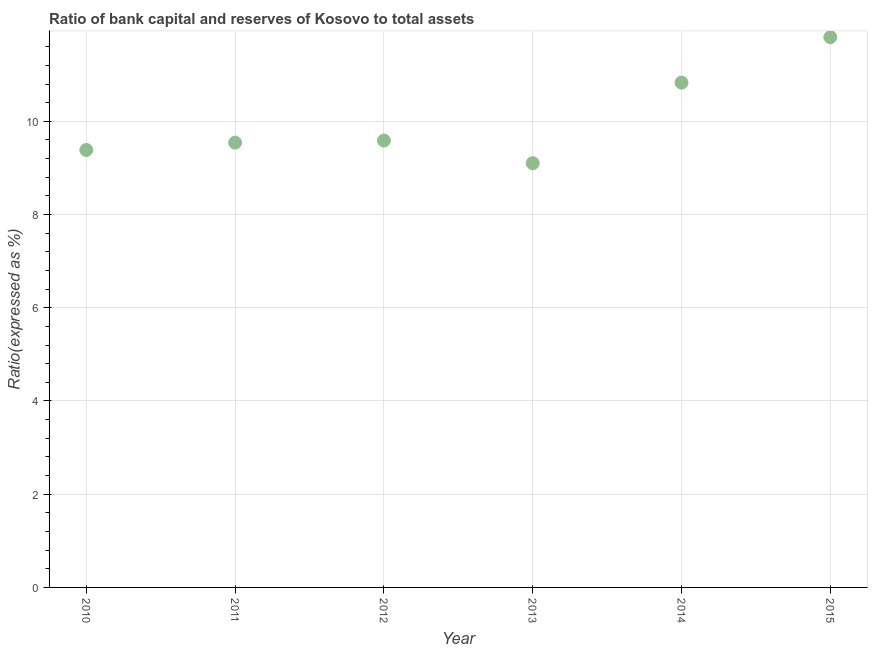What is the bank capital to assets ratio in 2010?
Your response must be concise. 9.39. Across all years, what is the maximum bank capital to assets ratio?
Provide a succinct answer. 11.81. Across all years, what is the minimum bank capital to assets ratio?
Your answer should be very brief. 9.1. In which year was the bank capital to assets ratio maximum?
Your answer should be compact. 2015. What is the sum of the bank capital to assets ratio?
Provide a short and direct response. 60.25. What is the difference between the bank capital to assets ratio in 2010 and 2012?
Your answer should be very brief. -0.2. What is the average bank capital to assets ratio per year?
Make the answer very short. 10.04. What is the median bank capital to assets ratio?
Your response must be concise. 9.56. Do a majority of the years between 2013 and 2014 (inclusive) have bank capital to assets ratio greater than 2.8 %?
Keep it short and to the point. Yes. What is the ratio of the bank capital to assets ratio in 2010 to that in 2013?
Offer a very short reply. 1.03. Is the bank capital to assets ratio in 2010 less than that in 2013?
Offer a terse response. No. What is the difference between the highest and the second highest bank capital to assets ratio?
Provide a succinct answer. 0.98. Is the sum of the bank capital to assets ratio in 2013 and 2015 greater than the maximum bank capital to assets ratio across all years?
Give a very brief answer. Yes. What is the difference between the highest and the lowest bank capital to assets ratio?
Your response must be concise. 2.7. In how many years, is the bank capital to assets ratio greater than the average bank capital to assets ratio taken over all years?
Offer a very short reply. 2. What is the difference between two consecutive major ticks on the Y-axis?
Your answer should be very brief. 2. Are the values on the major ticks of Y-axis written in scientific E-notation?
Your response must be concise. No. Does the graph contain any zero values?
Offer a terse response. No. What is the title of the graph?
Keep it short and to the point. Ratio of bank capital and reserves of Kosovo to total assets. What is the label or title of the X-axis?
Your answer should be very brief. Year. What is the label or title of the Y-axis?
Keep it short and to the point. Ratio(expressed as %). What is the Ratio(expressed as %) in 2010?
Provide a succinct answer. 9.39. What is the Ratio(expressed as %) in 2011?
Offer a terse response. 9.54. What is the Ratio(expressed as %) in 2012?
Offer a terse response. 9.59. What is the Ratio(expressed as %) in 2013?
Offer a very short reply. 9.1. What is the Ratio(expressed as %) in 2014?
Offer a very short reply. 10.83. What is the Ratio(expressed as %) in 2015?
Your answer should be very brief. 11.81. What is the difference between the Ratio(expressed as %) in 2010 and 2011?
Give a very brief answer. -0.16. What is the difference between the Ratio(expressed as %) in 2010 and 2012?
Your response must be concise. -0.2. What is the difference between the Ratio(expressed as %) in 2010 and 2013?
Provide a succinct answer. 0.28. What is the difference between the Ratio(expressed as %) in 2010 and 2014?
Provide a succinct answer. -1.44. What is the difference between the Ratio(expressed as %) in 2010 and 2015?
Offer a terse response. -2.42. What is the difference between the Ratio(expressed as %) in 2011 and 2012?
Your answer should be compact. -0.04. What is the difference between the Ratio(expressed as %) in 2011 and 2013?
Your answer should be compact. 0.44. What is the difference between the Ratio(expressed as %) in 2011 and 2014?
Keep it short and to the point. -1.29. What is the difference between the Ratio(expressed as %) in 2011 and 2015?
Offer a terse response. -2.26. What is the difference between the Ratio(expressed as %) in 2012 and 2013?
Provide a short and direct response. 0.49. What is the difference between the Ratio(expressed as %) in 2012 and 2014?
Provide a succinct answer. -1.24. What is the difference between the Ratio(expressed as %) in 2012 and 2015?
Your response must be concise. -2.22. What is the difference between the Ratio(expressed as %) in 2013 and 2014?
Your answer should be compact. -1.73. What is the difference between the Ratio(expressed as %) in 2013 and 2015?
Provide a succinct answer. -2.7. What is the difference between the Ratio(expressed as %) in 2014 and 2015?
Your answer should be very brief. -0.98. What is the ratio of the Ratio(expressed as %) in 2010 to that in 2013?
Keep it short and to the point. 1.03. What is the ratio of the Ratio(expressed as %) in 2010 to that in 2014?
Provide a short and direct response. 0.87. What is the ratio of the Ratio(expressed as %) in 2010 to that in 2015?
Offer a terse response. 0.8. What is the ratio of the Ratio(expressed as %) in 2011 to that in 2012?
Your answer should be very brief. 0.99. What is the ratio of the Ratio(expressed as %) in 2011 to that in 2013?
Ensure brevity in your answer.  1.05. What is the ratio of the Ratio(expressed as %) in 2011 to that in 2014?
Your answer should be compact. 0.88. What is the ratio of the Ratio(expressed as %) in 2011 to that in 2015?
Ensure brevity in your answer.  0.81. What is the ratio of the Ratio(expressed as %) in 2012 to that in 2013?
Offer a terse response. 1.05. What is the ratio of the Ratio(expressed as %) in 2012 to that in 2014?
Offer a terse response. 0.89. What is the ratio of the Ratio(expressed as %) in 2012 to that in 2015?
Give a very brief answer. 0.81. What is the ratio of the Ratio(expressed as %) in 2013 to that in 2014?
Offer a terse response. 0.84. What is the ratio of the Ratio(expressed as %) in 2013 to that in 2015?
Offer a terse response. 0.77. What is the ratio of the Ratio(expressed as %) in 2014 to that in 2015?
Give a very brief answer. 0.92. 